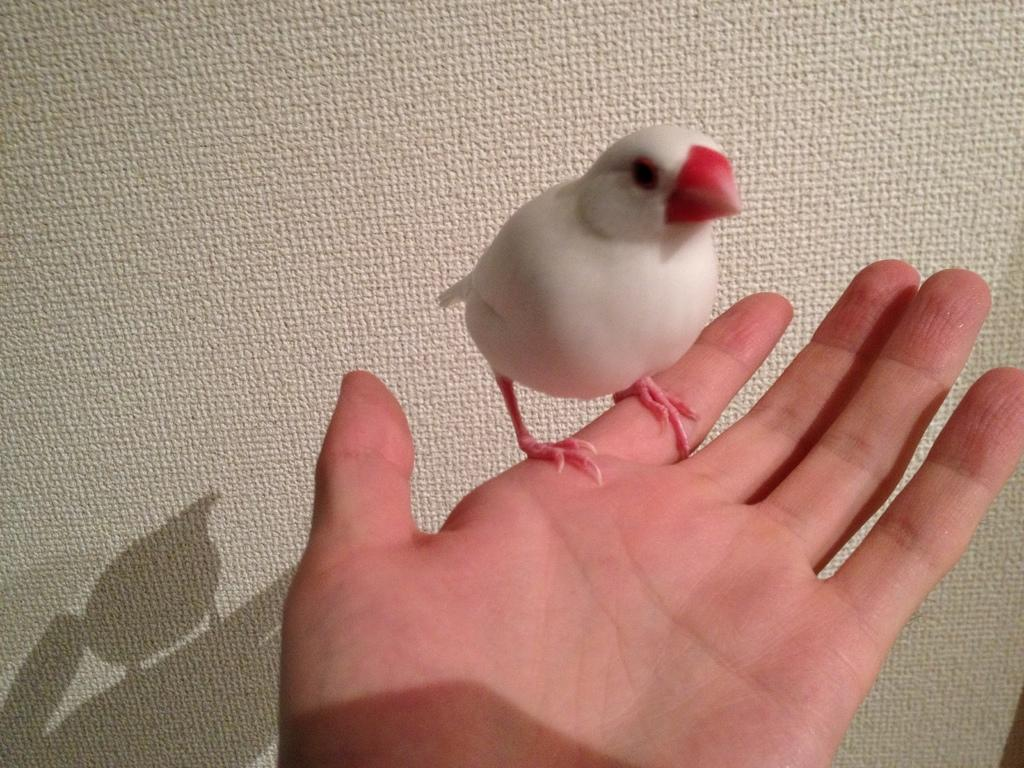What type of animal can be seen in the picture? There is a white bird in the picture. Where is the bird located in the image? The bird is standing on a person's hand. What can be seen in the background of the image? There is a cream-colored surface in the background of the image. What type of leaf is being processed by the person in the image? There is no leaf or any indication of a process in the image; it features a white bird standing on a person's hand. 